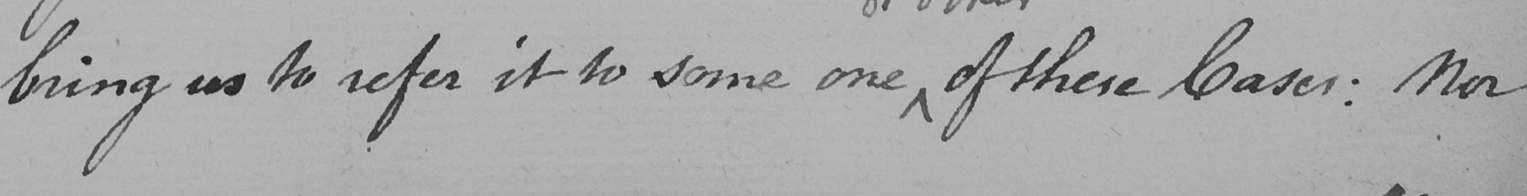Transcribe the text shown in this historical manuscript line. bring us to refer it to some one of these Cases :  Nor 